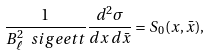<formula> <loc_0><loc_0><loc_500><loc_500>\frac { 1 } { B _ { \ell } ^ { 2 } \ s i g e e t t } \frac { d ^ { 2 } \sigma } { d x \, d \bar { x } } = S _ { 0 } ( x , \bar { x } ) ,</formula> 